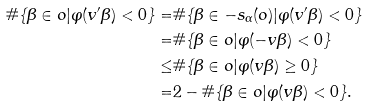<formula> <loc_0><loc_0><loc_500><loc_500>\# \{ \beta \in o | \varphi ( v ^ { \prime } \beta ) < 0 \} = & \# \{ \beta \in - s _ { \alpha } ( o ) | \varphi ( v ^ { \prime } \beta ) < 0 \} \\ = & \# \{ \beta \in o | \varphi ( - v \beta ) < 0 \} \\ \leq & \# \{ \beta \in o | \varphi ( v \beta ) \geq 0 \} \\ = & 2 - \# \{ \beta \in o | \varphi ( v \beta ) < 0 \} .</formula> 